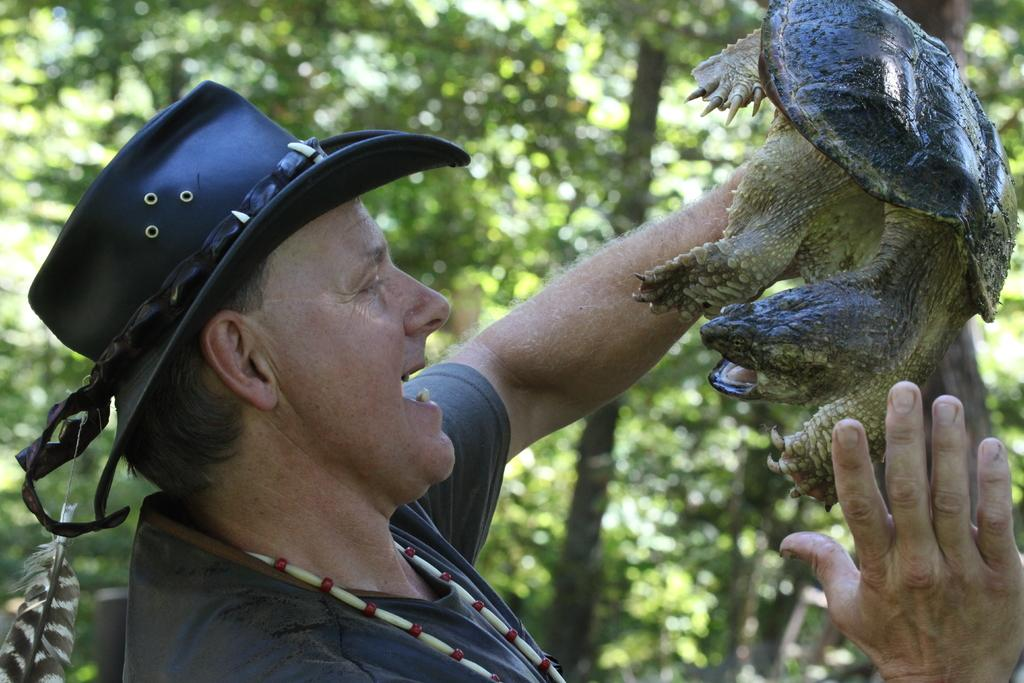What is the man in the image doing? The man is standing in the image and holding a tortoise in his hand. What is the man wearing on his head? The man is wearing a cap. What can be seen in the background of the image? There are trees visible in the background of the image. How would you describe the overall clarity of the image? The image is slightly blurry at the back. What type of cakes is the man serving in the image? There is no mention of cakes or serving in the image; the man is holding a tortoise. Can you see an apple in the man's hand in the image? There is no apple present in the image; the man is holding a tortoise. 